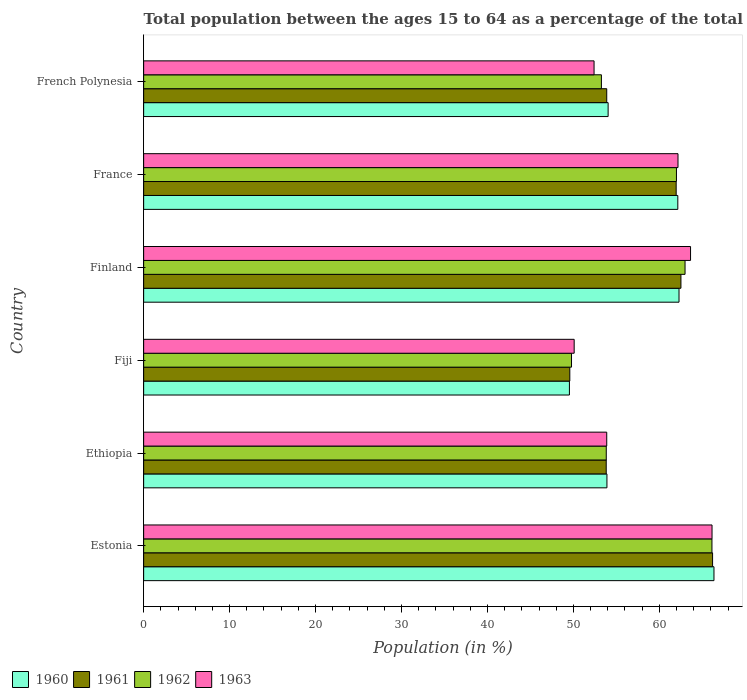How many groups of bars are there?
Your answer should be very brief. 6. Are the number of bars per tick equal to the number of legend labels?
Make the answer very short. Yes. Are the number of bars on each tick of the Y-axis equal?
Your response must be concise. Yes. How many bars are there on the 4th tick from the top?
Give a very brief answer. 4. How many bars are there on the 2nd tick from the bottom?
Make the answer very short. 4. What is the label of the 5th group of bars from the top?
Provide a short and direct response. Ethiopia. In how many cases, is the number of bars for a given country not equal to the number of legend labels?
Your response must be concise. 0. What is the percentage of the population ages 15 to 64 in 1963 in Finland?
Provide a succinct answer. 63.63. Across all countries, what is the maximum percentage of the population ages 15 to 64 in 1961?
Offer a terse response. 66.19. Across all countries, what is the minimum percentage of the population ages 15 to 64 in 1960?
Keep it short and to the point. 49.54. In which country was the percentage of the population ages 15 to 64 in 1962 maximum?
Keep it short and to the point. Estonia. In which country was the percentage of the population ages 15 to 64 in 1963 minimum?
Offer a very short reply. Fiji. What is the total percentage of the population ages 15 to 64 in 1962 in the graph?
Give a very brief answer. 347.95. What is the difference between the percentage of the population ages 15 to 64 in 1962 in Estonia and that in France?
Ensure brevity in your answer.  4.13. What is the difference between the percentage of the population ages 15 to 64 in 1962 in Estonia and the percentage of the population ages 15 to 64 in 1963 in Ethiopia?
Keep it short and to the point. 12.24. What is the average percentage of the population ages 15 to 64 in 1963 per country?
Offer a terse response. 58.05. What is the difference between the percentage of the population ages 15 to 64 in 1961 and percentage of the population ages 15 to 64 in 1962 in France?
Ensure brevity in your answer.  -0.03. What is the ratio of the percentage of the population ages 15 to 64 in 1963 in Ethiopia to that in Finland?
Provide a short and direct response. 0.85. Is the percentage of the population ages 15 to 64 in 1961 in France less than that in French Polynesia?
Offer a terse response. No. Is the difference between the percentage of the population ages 15 to 64 in 1961 in Ethiopia and French Polynesia greater than the difference between the percentage of the population ages 15 to 64 in 1962 in Ethiopia and French Polynesia?
Keep it short and to the point. No. What is the difference between the highest and the second highest percentage of the population ages 15 to 64 in 1962?
Make the answer very short. 3.13. What is the difference between the highest and the lowest percentage of the population ages 15 to 64 in 1961?
Your answer should be very brief. 16.61. In how many countries, is the percentage of the population ages 15 to 64 in 1963 greater than the average percentage of the population ages 15 to 64 in 1963 taken over all countries?
Provide a short and direct response. 3. Is it the case that in every country, the sum of the percentage of the population ages 15 to 64 in 1961 and percentage of the population ages 15 to 64 in 1962 is greater than the sum of percentage of the population ages 15 to 64 in 1960 and percentage of the population ages 15 to 64 in 1963?
Offer a terse response. No. What does the 2nd bar from the top in Estonia represents?
Offer a terse response. 1962. What does the 4th bar from the bottom in Ethiopia represents?
Provide a succinct answer. 1963. Is it the case that in every country, the sum of the percentage of the population ages 15 to 64 in 1963 and percentage of the population ages 15 to 64 in 1961 is greater than the percentage of the population ages 15 to 64 in 1962?
Give a very brief answer. Yes. How many bars are there?
Your answer should be very brief. 24. Does the graph contain any zero values?
Make the answer very short. No. Does the graph contain grids?
Your answer should be very brief. No. How many legend labels are there?
Keep it short and to the point. 4. What is the title of the graph?
Your response must be concise. Total population between the ages 15 to 64 as a percentage of the total population. Does "1973" appear as one of the legend labels in the graph?
Provide a short and direct response. No. What is the Population (in %) of 1960 in Estonia?
Give a very brief answer. 66.35. What is the Population (in %) in 1961 in Estonia?
Your answer should be very brief. 66.19. What is the Population (in %) of 1962 in Estonia?
Your answer should be compact. 66.12. What is the Population (in %) of 1963 in Estonia?
Your answer should be compact. 66.13. What is the Population (in %) of 1960 in Ethiopia?
Make the answer very short. 53.9. What is the Population (in %) of 1961 in Ethiopia?
Your response must be concise. 53.82. What is the Population (in %) of 1962 in Ethiopia?
Your answer should be very brief. 53.82. What is the Population (in %) in 1963 in Ethiopia?
Ensure brevity in your answer.  53.88. What is the Population (in %) in 1960 in Fiji?
Your response must be concise. 49.54. What is the Population (in %) of 1961 in Fiji?
Provide a succinct answer. 49.58. What is the Population (in %) of 1962 in Fiji?
Offer a terse response. 49.78. What is the Population (in %) of 1963 in Fiji?
Offer a very short reply. 50.09. What is the Population (in %) in 1960 in Finland?
Provide a succinct answer. 62.29. What is the Population (in %) of 1961 in Finland?
Provide a succinct answer. 62.51. What is the Population (in %) of 1962 in Finland?
Offer a very short reply. 62.99. What is the Population (in %) in 1963 in Finland?
Give a very brief answer. 63.63. What is the Population (in %) of 1960 in France?
Give a very brief answer. 62.15. What is the Population (in %) of 1961 in France?
Make the answer very short. 61.96. What is the Population (in %) in 1962 in France?
Your answer should be compact. 61.99. What is the Population (in %) of 1963 in France?
Make the answer very short. 62.17. What is the Population (in %) of 1960 in French Polynesia?
Make the answer very short. 54.04. What is the Population (in %) in 1961 in French Polynesia?
Provide a short and direct response. 53.88. What is the Population (in %) in 1962 in French Polynesia?
Make the answer very short. 53.26. What is the Population (in %) of 1963 in French Polynesia?
Ensure brevity in your answer.  52.4. Across all countries, what is the maximum Population (in %) in 1960?
Your answer should be compact. 66.35. Across all countries, what is the maximum Population (in %) of 1961?
Provide a short and direct response. 66.19. Across all countries, what is the maximum Population (in %) of 1962?
Make the answer very short. 66.12. Across all countries, what is the maximum Population (in %) of 1963?
Make the answer very short. 66.13. Across all countries, what is the minimum Population (in %) of 1960?
Provide a succinct answer. 49.54. Across all countries, what is the minimum Population (in %) of 1961?
Offer a terse response. 49.58. Across all countries, what is the minimum Population (in %) of 1962?
Provide a short and direct response. 49.78. Across all countries, what is the minimum Population (in %) of 1963?
Provide a short and direct response. 50.09. What is the total Population (in %) of 1960 in the graph?
Your answer should be compact. 348.26. What is the total Population (in %) of 1961 in the graph?
Keep it short and to the point. 347.93. What is the total Population (in %) in 1962 in the graph?
Give a very brief answer. 347.95. What is the total Population (in %) of 1963 in the graph?
Your response must be concise. 348.29. What is the difference between the Population (in %) of 1960 in Estonia and that in Ethiopia?
Give a very brief answer. 12.45. What is the difference between the Population (in %) of 1961 in Estonia and that in Ethiopia?
Give a very brief answer. 12.37. What is the difference between the Population (in %) of 1962 in Estonia and that in Ethiopia?
Make the answer very short. 12.3. What is the difference between the Population (in %) of 1963 in Estonia and that in Ethiopia?
Your answer should be very brief. 12.25. What is the difference between the Population (in %) of 1960 in Estonia and that in Fiji?
Your response must be concise. 16.82. What is the difference between the Population (in %) in 1961 in Estonia and that in Fiji?
Make the answer very short. 16.61. What is the difference between the Population (in %) of 1962 in Estonia and that in Fiji?
Offer a terse response. 16.34. What is the difference between the Population (in %) in 1963 in Estonia and that in Fiji?
Keep it short and to the point. 16.04. What is the difference between the Population (in %) of 1960 in Estonia and that in Finland?
Keep it short and to the point. 4.07. What is the difference between the Population (in %) in 1961 in Estonia and that in Finland?
Offer a terse response. 3.68. What is the difference between the Population (in %) in 1962 in Estonia and that in Finland?
Provide a short and direct response. 3.13. What is the difference between the Population (in %) in 1963 in Estonia and that in Finland?
Offer a very short reply. 2.5. What is the difference between the Population (in %) of 1960 in Estonia and that in France?
Provide a succinct answer. 4.21. What is the difference between the Population (in %) in 1961 in Estonia and that in France?
Make the answer very short. 4.24. What is the difference between the Population (in %) of 1962 in Estonia and that in France?
Your response must be concise. 4.13. What is the difference between the Population (in %) of 1963 in Estonia and that in France?
Ensure brevity in your answer.  3.96. What is the difference between the Population (in %) of 1960 in Estonia and that in French Polynesia?
Give a very brief answer. 12.32. What is the difference between the Population (in %) in 1961 in Estonia and that in French Polynesia?
Provide a short and direct response. 12.31. What is the difference between the Population (in %) of 1962 in Estonia and that in French Polynesia?
Your answer should be very brief. 12.86. What is the difference between the Population (in %) of 1963 in Estonia and that in French Polynesia?
Provide a succinct answer. 13.73. What is the difference between the Population (in %) in 1960 in Ethiopia and that in Fiji?
Your response must be concise. 4.36. What is the difference between the Population (in %) in 1961 in Ethiopia and that in Fiji?
Make the answer very short. 4.24. What is the difference between the Population (in %) in 1962 in Ethiopia and that in Fiji?
Your response must be concise. 4.04. What is the difference between the Population (in %) in 1963 in Ethiopia and that in Fiji?
Provide a short and direct response. 3.79. What is the difference between the Population (in %) of 1960 in Ethiopia and that in Finland?
Offer a terse response. -8.39. What is the difference between the Population (in %) in 1961 in Ethiopia and that in Finland?
Ensure brevity in your answer.  -8.69. What is the difference between the Population (in %) of 1962 in Ethiopia and that in Finland?
Provide a succinct answer. -9.16. What is the difference between the Population (in %) of 1963 in Ethiopia and that in Finland?
Your answer should be very brief. -9.75. What is the difference between the Population (in %) of 1960 in Ethiopia and that in France?
Give a very brief answer. -8.25. What is the difference between the Population (in %) of 1961 in Ethiopia and that in France?
Your answer should be compact. -8.14. What is the difference between the Population (in %) in 1962 in Ethiopia and that in France?
Your response must be concise. -8.17. What is the difference between the Population (in %) of 1963 in Ethiopia and that in France?
Offer a very short reply. -8.29. What is the difference between the Population (in %) of 1960 in Ethiopia and that in French Polynesia?
Provide a short and direct response. -0.14. What is the difference between the Population (in %) in 1961 in Ethiopia and that in French Polynesia?
Provide a short and direct response. -0.06. What is the difference between the Population (in %) of 1962 in Ethiopia and that in French Polynesia?
Make the answer very short. 0.56. What is the difference between the Population (in %) of 1963 in Ethiopia and that in French Polynesia?
Offer a terse response. 1.48. What is the difference between the Population (in %) of 1960 in Fiji and that in Finland?
Offer a terse response. -12.75. What is the difference between the Population (in %) of 1961 in Fiji and that in Finland?
Offer a terse response. -12.93. What is the difference between the Population (in %) in 1962 in Fiji and that in Finland?
Give a very brief answer. -13.21. What is the difference between the Population (in %) in 1963 in Fiji and that in Finland?
Your response must be concise. -13.54. What is the difference between the Population (in %) in 1960 in Fiji and that in France?
Your response must be concise. -12.61. What is the difference between the Population (in %) of 1961 in Fiji and that in France?
Provide a succinct answer. -12.37. What is the difference between the Population (in %) of 1962 in Fiji and that in France?
Ensure brevity in your answer.  -12.21. What is the difference between the Population (in %) of 1963 in Fiji and that in France?
Give a very brief answer. -12.08. What is the difference between the Population (in %) of 1960 in Fiji and that in French Polynesia?
Offer a terse response. -4.5. What is the difference between the Population (in %) of 1961 in Fiji and that in French Polynesia?
Your answer should be very brief. -4.3. What is the difference between the Population (in %) of 1962 in Fiji and that in French Polynesia?
Your response must be concise. -3.48. What is the difference between the Population (in %) in 1963 in Fiji and that in French Polynesia?
Your answer should be very brief. -2.31. What is the difference between the Population (in %) in 1960 in Finland and that in France?
Your answer should be very brief. 0.14. What is the difference between the Population (in %) of 1961 in Finland and that in France?
Provide a short and direct response. 0.56. What is the difference between the Population (in %) of 1963 in Finland and that in France?
Provide a short and direct response. 1.46. What is the difference between the Population (in %) of 1960 in Finland and that in French Polynesia?
Give a very brief answer. 8.25. What is the difference between the Population (in %) of 1961 in Finland and that in French Polynesia?
Your answer should be very brief. 8.63. What is the difference between the Population (in %) of 1962 in Finland and that in French Polynesia?
Your answer should be compact. 9.73. What is the difference between the Population (in %) in 1963 in Finland and that in French Polynesia?
Your response must be concise. 11.23. What is the difference between the Population (in %) in 1960 in France and that in French Polynesia?
Your answer should be very brief. 8.11. What is the difference between the Population (in %) of 1961 in France and that in French Polynesia?
Ensure brevity in your answer.  8.08. What is the difference between the Population (in %) of 1962 in France and that in French Polynesia?
Offer a terse response. 8.73. What is the difference between the Population (in %) of 1963 in France and that in French Polynesia?
Offer a very short reply. 9.77. What is the difference between the Population (in %) in 1960 in Estonia and the Population (in %) in 1961 in Ethiopia?
Give a very brief answer. 12.54. What is the difference between the Population (in %) of 1960 in Estonia and the Population (in %) of 1962 in Ethiopia?
Keep it short and to the point. 12.53. What is the difference between the Population (in %) of 1960 in Estonia and the Population (in %) of 1963 in Ethiopia?
Your answer should be compact. 12.48. What is the difference between the Population (in %) in 1961 in Estonia and the Population (in %) in 1962 in Ethiopia?
Your response must be concise. 12.37. What is the difference between the Population (in %) of 1961 in Estonia and the Population (in %) of 1963 in Ethiopia?
Offer a very short reply. 12.31. What is the difference between the Population (in %) of 1962 in Estonia and the Population (in %) of 1963 in Ethiopia?
Offer a very short reply. 12.24. What is the difference between the Population (in %) of 1960 in Estonia and the Population (in %) of 1961 in Fiji?
Provide a short and direct response. 16.77. What is the difference between the Population (in %) in 1960 in Estonia and the Population (in %) in 1962 in Fiji?
Your answer should be very brief. 16.57. What is the difference between the Population (in %) in 1960 in Estonia and the Population (in %) in 1963 in Fiji?
Offer a terse response. 16.26. What is the difference between the Population (in %) in 1961 in Estonia and the Population (in %) in 1962 in Fiji?
Give a very brief answer. 16.41. What is the difference between the Population (in %) of 1961 in Estonia and the Population (in %) of 1963 in Fiji?
Make the answer very short. 16.1. What is the difference between the Population (in %) of 1962 in Estonia and the Population (in %) of 1963 in Fiji?
Provide a short and direct response. 16.03. What is the difference between the Population (in %) in 1960 in Estonia and the Population (in %) in 1961 in Finland?
Provide a succinct answer. 3.84. What is the difference between the Population (in %) in 1960 in Estonia and the Population (in %) in 1962 in Finland?
Give a very brief answer. 3.37. What is the difference between the Population (in %) of 1960 in Estonia and the Population (in %) of 1963 in Finland?
Your answer should be very brief. 2.73. What is the difference between the Population (in %) in 1961 in Estonia and the Population (in %) in 1962 in Finland?
Your response must be concise. 3.2. What is the difference between the Population (in %) of 1961 in Estonia and the Population (in %) of 1963 in Finland?
Keep it short and to the point. 2.56. What is the difference between the Population (in %) of 1962 in Estonia and the Population (in %) of 1963 in Finland?
Provide a short and direct response. 2.49. What is the difference between the Population (in %) of 1960 in Estonia and the Population (in %) of 1961 in France?
Offer a very short reply. 4.4. What is the difference between the Population (in %) of 1960 in Estonia and the Population (in %) of 1962 in France?
Give a very brief answer. 4.37. What is the difference between the Population (in %) in 1960 in Estonia and the Population (in %) in 1963 in France?
Offer a terse response. 4.19. What is the difference between the Population (in %) in 1961 in Estonia and the Population (in %) in 1962 in France?
Provide a succinct answer. 4.2. What is the difference between the Population (in %) of 1961 in Estonia and the Population (in %) of 1963 in France?
Make the answer very short. 4.02. What is the difference between the Population (in %) of 1962 in Estonia and the Population (in %) of 1963 in France?
Offer a very short reply. 3.95. What is the difference between the Population (in %) of 1960 in Estonia and the Population (in %) of 1961 in French Polynesia?
Ensure brevity in your answer.  12.48. What is the difference between the Population (in %) of 1960 in Estonia and the Population (in %) of 1962 in French Polynesia?
Your answer should be very brief. 13.1. What is the difference between the Population (in %) in 1960 in Estonia and the Population (in %) in 1963 in French Polynesia?
Offer a terse response. 13.95. What is the difference between the Population (in %) of 1961 in Estonia and the Population (in %) of 1962 in French Polynesia?
Ensure brevity in your answer.  12.93. What is the difference between the Population (in %) in 1961 in Estonia and the Population (in %) in 1963 in French Polynesia?
Your answer should be compact. 13.79. What is the difference between the Population (in %) of 1962 in Estonia and the Population (in %) of 1963 in French Polynesia?
Provide a short and direct response. 13.72. What is the difference between the Population (in %) in 1960 in Ethiopia and the Population (in %) in 1961 in Fiji?
Give a very brief answer. 4.32. What is the difference between the Population (in %) of 1960 in Ethiopia and the Population (in %) of 1962 in Fiji?
Your answer should be very brief. 4.12. What is the difference between the Population (in %) of 1960 in Ethiopia and the Population (in %) of 1963 in Fiji?
Give a very brief answer. 3.81. What is the difference between the Population (in %) in 1961 in Ethiopia and the Population (in %) in 1962 in Fiji?
Make the answer very short. 4.04. What is the difference between the Population (in %) in 1961 in Ethiopia and the Population (in %) in 1963 in Fiji?
Your answer should be very brief. 3.73. What is the difference between the Population (in %) of 1962 in Ethiopia and the Population (in %) of 1963 in Fiji?
Your answer should be very brief. 3.73. What is the difference between the Population (in %) of 1960 in Ethiopia and the Population (in %) of 1961 in Finland?
Provide a short and direct response. -8.61. What is the difference between the Population (in %) of 1960 in Ethiopia and the Population (in %) of 1962 in Finland?
Offer a terse response. -9.09. What is the difference between the Population (in %) in 1960 in Ethiopia and the Population (in %) in 1963 in Finland?
Offer a terse response. -9.73. What is the difference between the Population (in %) of 1961 in Ethiopia and the Population (in %) of 1962 in Finland?
Your response must be concise. -9.17. What is the difference between the Population (in %) in 1961 in Ethiopia and the Population (in %) in 1963 in Finland?
Ensure brevity in your answer.  -9.81. What is the difference between the Population (in %) in 1962 in Ethiopia and the Population (in %) in 1963 in Finland?
Offer a terse response. -9.81. What is the difference between the Population (in %) of 1960 in Ethiopia and the Population (in %) of 1961 in France?
Offer a very short reply. -8.06. What is the difference between the Population (in %) in 1960 in Ethiopia and the Population (in %) in 1962 in France?
Ensure brevity in your answer.  -8.09. What is the difference between the Population (in %) of 1960 in Ethiopia and the Population (in %) of 1963 in France?
Keep it short and to the point. -8.27. What is the difference between the Population (in %) in 1961 in Ethiopia and the Population (in %) in 1962 in France?
Ensure brevity in your answer.  -8.17. What is the difference between the Population (in %) in 1961 in Ethiopia and the Population (in %) in 1963 in France?
Provide a succinct answer. -8.35. What is the difference between the Population (in %) of 1962 in Ethiopia and the Population (in %) of 1963 in France?
Offer a very short reply. -8.34. What is the difference between the Population (in %) of 1960 in Ethiopia and the Population (in %) of 1961 in French Polynesia?
Provide a short and direct response. 0.02. What is the difference between the Population (in %) in 1960 in Ethiopia and the Population (in %) in 1962 in French Polynesia?
Your response must be concise. 0.64. What is the difference between the Population (in %) of 1960 in Ethiopia and the Population (in %) of 1963 in French Polynesia?
Your response must be concise. 1.5. What is the difference between the Population (in %) in 1961 in Ethiopia and the Population (in %) in 1962 in French Polynesia?
Your response must be concise. 0.56. What is the difference between the Population (in %) of 1961 in Ethiopia and the Population (in %) of 1963 in French Polynesia?
Offer a very short reply. 1.42. What is the difference between the Population (in %) in 1962 in Ethiopia and the Population (in %) in 1963 in French Polynesia?
Offer a terse response. 1.42. What is the difference between the Population (in %) in 1960 in Fiji and the Population (in %) in 1961 in Finland?
Provide a short and direct response. -12.97. What is the difference between the Population (in %) of 1960 in Fiji and the Population (in %) of 1962 in Finland?
Offer a very short reply. -13.45. What is the difference between the Population (in %) in 1960 in Fiji and the Population (in %) in 1963 in Finland?
Ensure brevity in your answer.  -14.09. What is the difference between the Population (in %) of 1961 in Fiji and the Population (in %) of 1962 in Finland?
Your response must be concise. -13.41. What is the difference between the Population (in %) of 1961 in Fiji and the Population (in %) of 1963 in Finland?
Offer a terse response. -14.05. What is the difference between the Population (in %) of 1962 in Fiji and the Population (in %) of 1963 in Finland?
Provide a short and direct response. -13.85. What is the difference between the Population (in %) in 1960 in Fiji and the Population (in %) in 1961 in France?
Your response must be concise. -12.42. What is the difference between the Population (in %) of 1960 in Fiji and the Population (in %) of 1962 in France?
Your answer should be very brief. -12.45. What is the difference between the Population (in %) of 1960 in Fiji and the Population (in %) of 1963 in France?
Provide a succinct answer. -12.63. What is the difference between the Population (in %) in 1961 in Fiji and the Population (in %) in 1962 in France?
Offer a very short reply. -12.41. What is the difference between the Population (in %) of 1961 in Fiji and the Population (in %) of 1963 in France?
Provide a short and direct response. -12.59. What is the difference between the Population (in %) of 1962 in Fiji and the Population (in %) of 1963 in France?
Give a very brief answer. -12.39. What is the difference between the Population (in %) in 1960 in Fiji and the Population (in %) in 1961 in French Polynesia?
Give a very brief answer. -4.34. What is the difference between the Population (in %) of 1960 in Fiji and the Population (in %) of 1962 in French Polynesia?
Your answer should be very brief. -3.72. What is the difference between the Population (in %) in 1960 in Fiji and the Population (in %) in 1963 in French Polynesia?
Provide a short and direct response. -2.87. What is the difference between the Population (in %) in 1961 in Fiji and the Population (in %) in 1962 in French Polynesia?
Offer a very short reply. -3.68. What is the difference between the Population (in %) of 1961 in Fiji and the Population (in %) of 1963 in French Polynesia?
Offer a terse response. -2.82. What is the difference between the Population (in %) of 1962 in Fiji and the Population (in %) of 1963 in French Polynesia?
Your answer should be compact. -2.62. What is the difference between the Population (in %) in 1960 in Finland and the Population (in %) in 1961 in France?
Provide a short and direct response. 0.33. What is the difference between the Population (in %) of 1960 in Finland and the Population (in %) of 1962 in France?
Provide a succinct answer. 0.3. What is the difference between the Population (in %) in 1960 in Finland and the Population (in %) in 1963 in France?
Your response must be concise. 0.12. What is the difference between the Population (in %) of 1961 in Finland and the Population (in %) of 1962 in France?
Make the answer very short. 0.52. What is the difference between the Population (in %) of 1961 in Finland and the Population (in %) of 1963 in France?
Give a very brief answer. 0.34. What is the difference between the Population (in %) in 1962 in Finland and the Population (in %) in 1963 in France?
Your answer should be very brief. 0.82. What is the difference between the Population (in %) in 1960 in Finland and the Population (in %) in 1961 in French Polynesia?
Give a very brief answer. 8.41. What is the difference between the Population (in %) of 1960 in Finland and the Population (in %) of 1962 in French Polynesia?
Offer a very short reply. 9.03. What is the difference between the Population (in %) of 1960 in Finland and the Population (in %) of 1963 in French Polynesia?
Give a very brief answer. 9.88. What is the difference between the Population (in %) of 1961 in Finland and the Population (in %) of 1962 in French Polynesia?
Provide a short and direct response. 9.25. What is the difference between the Population (in %) in 1961 in Finland and the Population (in %) in 1963 in French Polynesia?
Give a very brief answer. 10.11. What is the difference between the Population (in %) of 1962 in Finland and the Population (in %) of 1963 in French Polynesia?
Your response must be concise. 10.59. What is the difference between the Population (in %) of 1960 in France and the Population (in %) of 1961 in French Polynesia?
Make the answer very short. 8.27. What is the difference between the Population (in %) in 1960 in France and the Population (in %) in 1962 in French Polynesia?
Ensure brevity in your answer.  8.89. What is the difference between the Population (in %) in 1960 in France and the Population (in %) in 1963 in French Polynesia?
Ensure brevity in your answer.  9.75. What is the difference between the Population (in %) of 1961 in France and the Population (in %) of 1962 in French Polynesia?
Your answer should be compact. 8.7. What is the difference between the Population (in %) of 1961 in France and the Population (in %) of 1963 in French Polynesia?
Offer a terse response. 9.55. What is the difference between the Population (in %) of 1962 in France and the Population (in %) of 1963 in French Polynesia?
Provide a succinct answer. 9.59. What is the average Population (in %) in 1960 per country?
Offer a terse response. 58.04. What is the average Population (in %) of 1961 per country?
Your answer should be very brief. 57.99. What is the average Population (in %) in 1962 per country?
Make the answer very short. 57.99. What is the average Population (in %) in 1963 per country?
Keep it short and to the point. 58.05. What is the difference between the Population (in %) in 1960 and Population (in %) in 1961 in Estonia?
Your answer should be compact. 0.16. What is the difference between the Population (in %) of 1960 and Population (in %) of 1962 in Estonia?
Give a very brief answer. 0.24. What is the difference between the Population (in %) of 1960 and Population (in %) of 1963 in Estonia?
Give a very brief answer. 0.23. What is the difference between the Population (in %) of 1961 and Population (in %) of 1962 in Estonia?
Offer a very short reply. 0.07. What is the difference between the Population (in %) of 1961 and Population (in %) of 1963 in Estonia?
Provide a short and direct response. 0.06. What is the difference between the Population (in %) in 1962 and Population (in %) in 1963 in Estonia?
Your answer should be compact. -0.01. What is the difference between the Population (in %) of 1960 and Population (in %) of 1961 in Ethiopia?
Provide a short and direct response. 0.08. What is the difference between the Population (in %) of 1960 and Population (in %) of 1962 in Ethiopia?
Keep it short and to the point. 0.08. What is the difference between the Population (in %) of 1960 and Population (in %) of 1963 in Ethiopia?
Provide a short and direct response. 0.02. What is the difference between the Population (in %) in 1961 and Population (in %) in 1962 in Ethiopia?
Offer a terse response. -0.01. What is the difference between the Population (in %) of 1961 and Population (in %) of 1963 in Ethiopia?
Provide a short and direct response. -0.06. What is the difference between the Population (in %) of 1962 and Population (in %) of 1963 in Ethiopia?
Your answer should be compact. -0.05. What is the difference between the Population (in %) in 1960 and Population (in %) in 1961 in Fiji?
Make the answer very short. -0.05. What is the difference between the Population (in %) of 1960 and Population (in %) of 1962 in Fiji?
Your answer should be very brief. -0.24. What is the difference between the Population (in %) of 1960 and Population (in %) of 1963 in Fiji?
Keep it short and to the point. -0.55. What is the difference between the Population (in %) of 1961 and Population (in %) of 1962 in Fiji?
Make the answer very short. -0.2. What is the difference between the Population (in %) of 1961 and Population (in %) of 1963 in Fiji?
Ensure brevity in your answer.  -0.51. What is the difference between the Population (in %) in 1962 and Population (in %) in 1963 in Fiji?
Your response must be concise. -0.31. What is the difference between the Population (in %) in 1960 and Population (in %) in 1961 in Finland?
Your response must be concise. -0.22. What is the difference between the Population (in %) of 1960 and Population (in %) of 1962 in Finland?
Offer a terse response. -0.7. What is the difference between the Population (in %) in 1960 and Population (in %) in 1963 in Finland?
Provide a succinct answer. -1.34. What is the difference between the Population (in %) in 1961 and Population (in %) in 1962 in Finland?
Provide a succinct answer. -0.48. What is the difference between the Population (in %) in 1961 and Population (in %) in 1963 in Finland?
Offer a terse response. -1.12. What is the difference between the Population (in %) in 1962 and Population (in %) in 1963 in Finland?
Your answer should be very brief. -0.64. What is the difference between the Population (in %) of 1960 and Population (in %) of 1961 in France?
Provide a short and direct response. 0.19. What is the difference between the Population (in %) in 1960 and Population (in %) in 1962 in France?
Your answer should be compact. 0.16. What is the difference between the Population (in %) of 1960 and Population (in %) of 1963 in France?
Give a very brief answer. -0.02. What is the difference between the Population (in %) in 1961 and Population (in %) in 1962 in France?
Ensure brevity in your answer.  -0.03. What is the difference between the Population (in %) in 1961 and Population (in %) in 1963 in France?
Your answer should be very brief. -0.21. What is the difference between the Population (in %) of 1962 and Population (in %) of 1963 in France?
Your answer should be compact. -0.18. What is the difference between the Population (in %) of 1960 and Population (in %) of 1961 in French Polynesia?
Keep it short and to the point. 0.16. What is the difference between the Population (in %) of 1960 and Population (in %) of 1962 in French Polynesia?
Provide a succinct answer. 0.78. What is the difference between the Population (in %) in 1960 and Population (in %) in 1963 in French Polynesia?
Offer a terse response. 1.64. What is the difference between the Population (in %) of 1961 and Population (in %) of 1962 in French Polynesia?
Your response must be concise. 0.62. What is the difference between the Population (in %) in 1961 and Population (in %) in 1963 in French Polynesia?
Your answer should be compact. 1.48. What is the difference between the Population (in %) of 1962 and Population (in %) of 1963 in French Polynesia?
Your answer should be very brief. 0.86. What is the ratio of the Population (in %) in 1960 in Estonia to that in Ethiopia?
Your answer should be very brief. 1.23. What is the ratio of the Population (in %) in 1961 in Estonia to that in Ethiopia?
Provide a succinct answer. 1.23. What is the ratio of the Population (in %) of 1962 in Estonia to that in Ethiopia?
Your answer should be very brief. 1.23. What is the ratio of the Population (in %) of 1963 in Estonia to that in Ethiopia?
Offer a very short reply. 1.23. What is the ratio of the Population (in %) in 1960 in Estonia to that in Fiji?
Your answer should be very brief. 1.34. What is the ratio of the Population (in %) of 1961 in Estonia to that in Fiji?
Your answer should be compact. 1.33. What is the ratio of the Population (in %) in 1962 in Estonia to that in Fiji?
Your answer should be compact. 1.33. What is the ratio of the Population (in %) of 1963 in Estonia to that in Fiji?
Your answer should be very brief. 1.32. What is the ratio of the Population (in %) in 1960 in Estonia to that in Finland?
Offer a terse response. 1.07. What is the ratio of the Population (in %) of 1961 in Estonia to that in Finland?
Ensure brevity in your answer.  1.06. What is the ratio of the Population (in %) in 1962 in Estonia to that in Finland?
Provide a succinct answer. 1.05. What is the ratio of the Population (in %) in 1963 in Estonia to that in Finland?
Your response must be concise. 1.04. What is the ratio of the Population (in %) in 1960 in Estonia to that in France?
Ensure brevity in your answer.  1.07. What is the ratio of the Population (in %) of 1961 in Estonia to that in France?
Provide a short and direct response. 1.07. What is the ratio of the Population (in %) in 1962 in Estonia to that in France?
Provide a succinct answer. 1.07. What is the ratio of the Population (in %) of 1963 in Estonia to that in France?
Provide a short and direct response. 1.06. What is the ratio of the Population (in %) of 1960 in Estonia to that in French Polynesia?
Offer a terse response. 1.23. What is the ratio of the Population (in %) in 1961 in Estonia to that in French Polynesia?
Offer a terse response. 1.23. What is the ratio of the Population (in %) in 1962 in Estonia to that in French Polynesia?
Make the answer very short. 1.24. What is the ratio of the Population (in %) of 1963 in Estonia to that in French Polynesia?
Provide a short and direct response. 1.26. What is the ratio of the Population (in %) in 1960 in Ethiopia to that in Fiji?
Make the answer very short. 1.09. What is the ratio of the Population (in %) in 1961 in Ethiopia to that in Fiji?
Provide a short and direct response. 1.09. What is the ratio of the Population (in %) of 1962 in Ethiopia to that in Fiji?
Your response must be concise. 1.08. What is the ratio of the Population (in %) of 1963 in Ethiopia to that in Fiji?
Offer a very short reply. 1.08. What is the ratio of the Population (in %) of 1960 in Ethiopia to that in Finland?
Offer a very short reply. 0.87. What is the ratio of the Population (in %) in 1961 in Ethiopia to that in Finland?
Offer a terse response. 0.86. What is the ratio of the Population (in %) in 1962 in Ethiopia to that in Finland?
Make the answer very short. 0.85. What is the ratio of the Population (in %) of 1963 in Ethiopia to that in Finland?
Keep it short and to the point. 0.85. What is the ratio of the Population (in %) of 1960 in Ethiopia to that in France?
Keep it short and to the point. 0.87. What is the ratio of the Population (in %) in 1961 in Ethiopia to that in France?
Provide a succinct answer. 0.87. What is the ratio of the Population (in %) in 1962 in Ethiopia to that in France?
Make the answer very short. 0.87. What is the ratio of the Population (in %) in 1963 in Ethiopia to that in France?
Make the answer very short. 0.87. What is the ratio of the Population (in %) of 1961 in Ethiopia to that in French Polynesia?
Provide a succinct answer. 1. What is the ratio of the Population (in %) in 1962 in Ethiopia to that in French Polynesia?
Provide a succinct answer. 1.01. What is the ratio of the Population (in %) in 1963 in Ethiopia to that in French Polynesia?
Your answer should be compact. 1.03. What is the ratio of the Population (in %) in 1960 in Fiji to that in Finland?
Ensure brevity in your answer.  0.8. What is the ratio of the Population (in %) in 1961 in Fiji to that in Finland?
Make the answer very short. 0.79. What is the ratio of the Population (in %) in 1962 in Fiji to that in Finland?
Offer a very short reply. 0.79. What is the ratio of the Population (in %) in 1963 in Fiji to that in Finland?
Offer a terse response. 0.79. What is the ratio of the Population (in %) of 1960 in Fiji to that in France?
Your answer should be very brief. 0.8. What is the ratio of the Population (in %) in 1961 in Fiji to that in France?
Keep it short and to the point. 0.8. What is the ratio of the Population (in %) of 1962 in Fiji to that in France?
Offer a terse response. 0.8. What is the ratio of the Population (in %) of 1963 in Fiji to that in France?
Offer a terse response. 0.81. What is the ratio of the Population (in %) of 1961 in Fiji to that in French Polynesia?
Your response must be concise. 0.92. What is the ratio of the Population (in %) of 1962 in Fiji to that in French Polynesia?
Offer a very short reply. 0.93. What is the ratio of the Population (in %) in 1963 in Fiji to that in French Polynesia?
Your response must be concise. 0.96. What is the ratio of the Population (in %) in 1960 in Finland to that in France?
Your answer should be compact. 1. What is the ratio of the Population (in %) in 1962 in Finland to that in France?
Offer a terse response. 1.02. What is the ratio of the Population (in %) of 1963 in Finland to that in France?
Provide a succinct answer. 1.02. What is the ratio of the Population (in %) in 1960 in Finland to that in French Polynesia?
Your answer should be compact. 1.15. What is the ratio of the Population (in %) in 1961 in Finland to that in French Polynesia?
Your answer should be compact. 1.16. What is the ratio of the Population (in %) in 1962 in Finland to that in French Polynesia?
Ensure brevity in your answer.  1.18. What is the ratio of the Population (in %) of 1963 in Finland to that in French Polynesia?
Keep it short and to the point. 1.21. What is the ratio of the Population (in %) in 1960 in France to that in French Polynesia?
Offer a terse response. 1.15. What is the ratio of the Population (in %) in 1961 in France to that in French Polynesia?
Offer a terse response. 1.15. What is the ratio of the Population (in %) in 1962 in France to that in French Polynesia?
Keep it short and to the point. 1.16. What is the ratio of the Population (in %) of 1963 in France to that in French Polynesia?
Offer a very short reply. 1.19. What is the difference between the highest and the second highest Population (in %) of 1960?
Give a very brief answer. 4.07. What is the difference between the highest and the second highest Population (in %) in 1961?
Provide a succinct answer. 3.68. What is the difference between the highest and the second highest Population (in %) of 1962?
Offer a very short reply. 3.13. What is the difference between the highest and the second highest Population (in %) of 1963?
Ensure brevity in your answer.  2.5. What is the difference between the highest and the lowest Population (in %) of 1960?
Your answer should be compact. 16.82. What is the difference between the highest and the lowest Population (in %) of 1961?
Your response must be concise. 16.61. What is the difference between the highest and the lowest Population (in %) in 1962?
Your response must be concise. 16.34. What is the difference between the highest and the lowest Population (in %) in 1963?
Offer a very short reply. 16.04. 